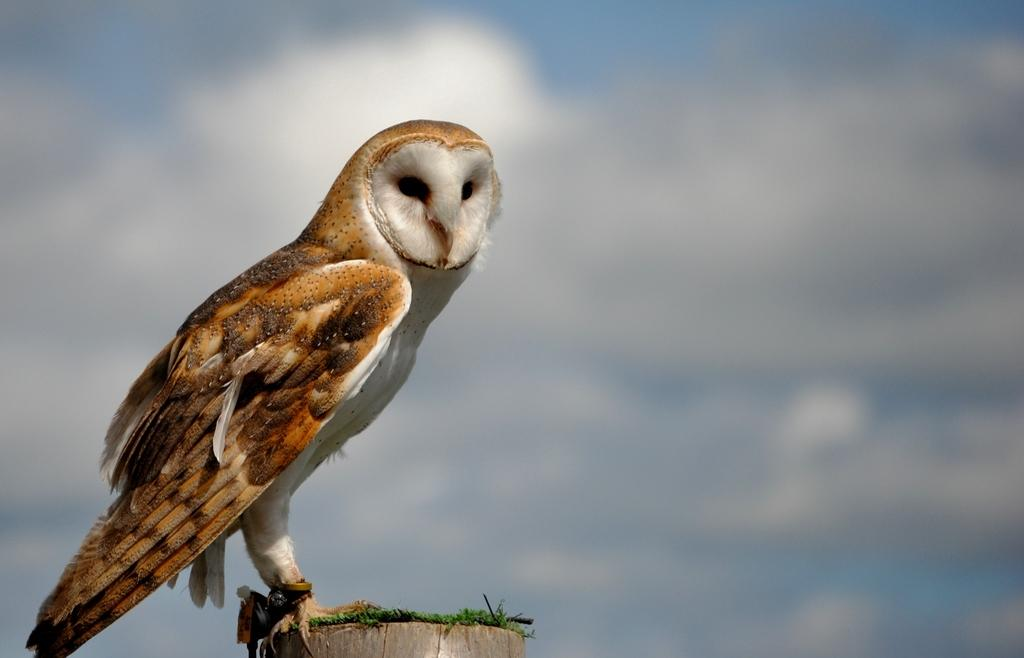What is the main subject in the foreground of the image? There is a bird in the foreground of the image. What is the bird perched on? The bird is on a wooden stick. What can be seen in the background of the image? There is sky visible in the background of the image, and there are clouds present. What type of whip is the bird using to fly in the image? There is no whip present in the image, and the bird is not using any tool to fly. 